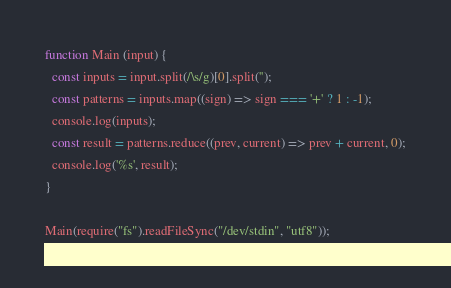<code> <loc_0><loc_0><loc_500><loc_500><_JavaScript_>function Main (input) {
  const inputs = input.split(/\s/g)[0].split('');
  const patterns = inputs.map((sign) => sign === '+' ? 1 : -1);
  console.log(inputs);
  const result = patterns.reduce((prev, current) => prev + current, 0);
  console.log('%s', result);
}

Main(require("fs").readFileSync("/dev/stdin", "utf8"));
</code> 